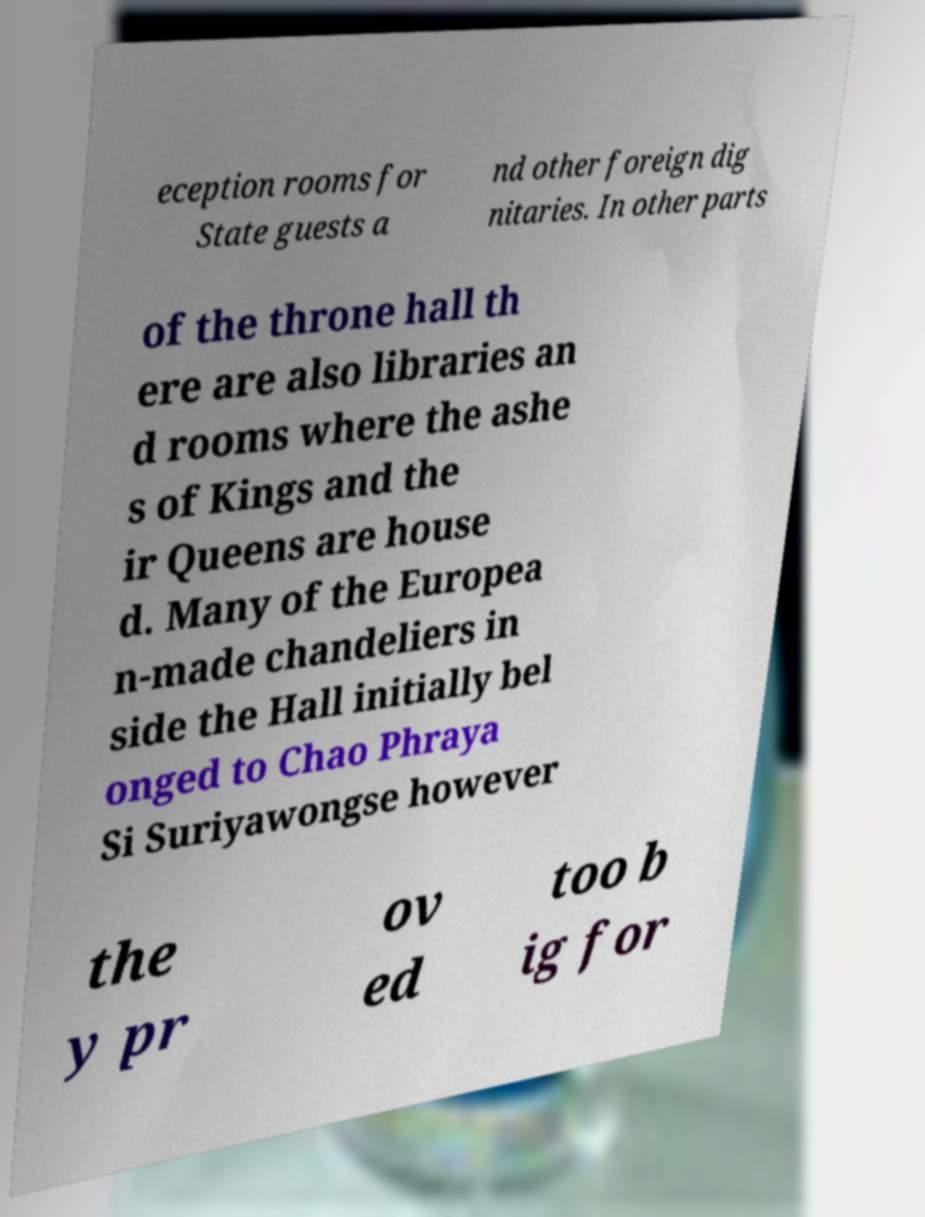Please read and relay the text visible in this image. What does it say? eception rooms for State guests a nd other foreign dig nitaries. In other parts of the throne hall th ere are also libraries an d rooms where the ashe s of Kings and the ir Queens are house d. Many of the Europea n-made chandeliers in side the Hall initially bel onged to Chao Phraya Si Suriyawongse however the y pr ov ed too b ig for 